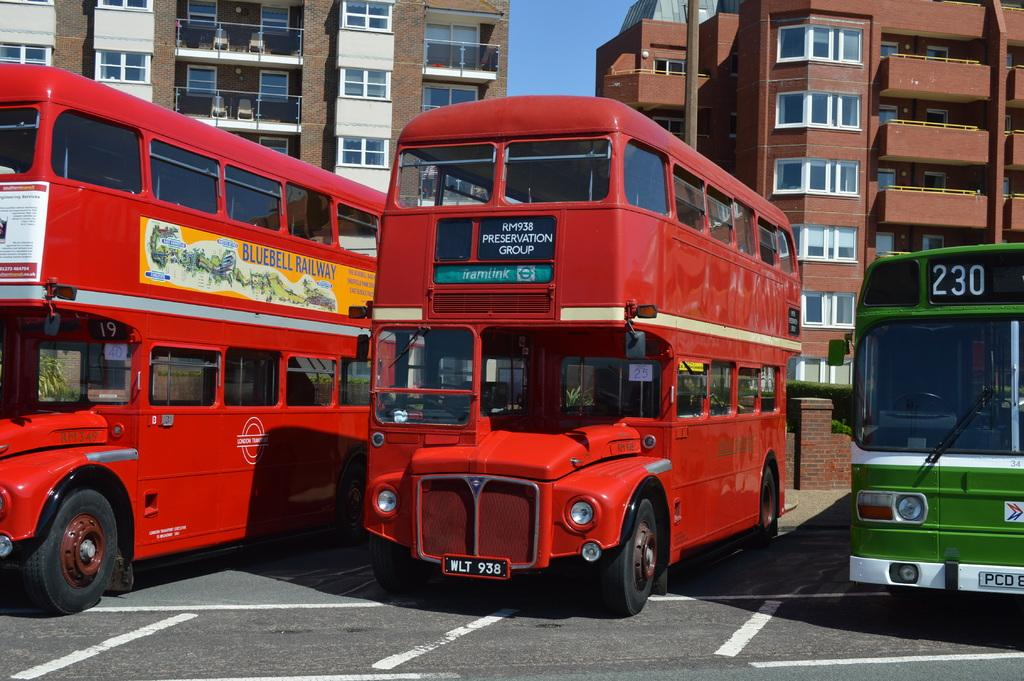How many buses can be seen in the image? There are three buses in the image. Where are the buses located? The buses are on the road. What can be seen in the background of the image? There is a sky and buildings visible in the background of the image. How many trees are visible in the image? There are no trees visible in the image; it only shows buses on the road and buildings in the background. 